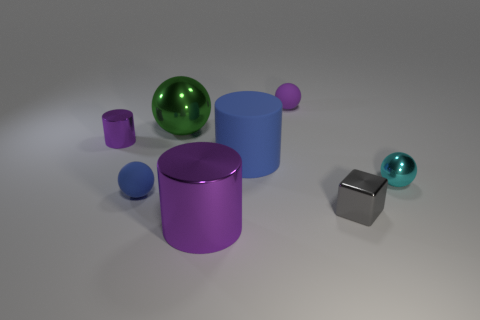What is the shape of the purple shiny thing that is the same size as the blue cylinder?
Give a very brief answer. Cylinder. There is a tiny matte sphere behind the tiny matte sphere in front of the metallic sphere to the right of the purple sphere; what is its color?
Your response must be concise. Purple. Do the tiny purple metal object and the green thing have the same shape?
Make the answer very short. No. Are there the same number of purple balls that are right of the gray shiny cube and gray objects?
Your response must be concise. No. What number of other things are there of the same material as the small gray thing
Your answer should be very brief. 4. There is a cylinder to the right of the big metal cylinder; does it have the same size as the purple metal thing that is to the left of the green metal thing?
Keep it short and to the point. No. How many objects are either small shiny things that are on the left side of the tiny shiny sphere or balls behind the big metal sphere?
Offer a very short reply. 3. Are there any other things that have the same shape as the purple rubber thing?
Provide a succinct answer. Yes. Does the small matte ball that is behind the large blue thing have the same color as the cylinder in front of the small gray shiny object?
Offer a terse response. Yes. How many matte things are either big purple cylinders or cyan spheres?
Make the answer very short. 0. 